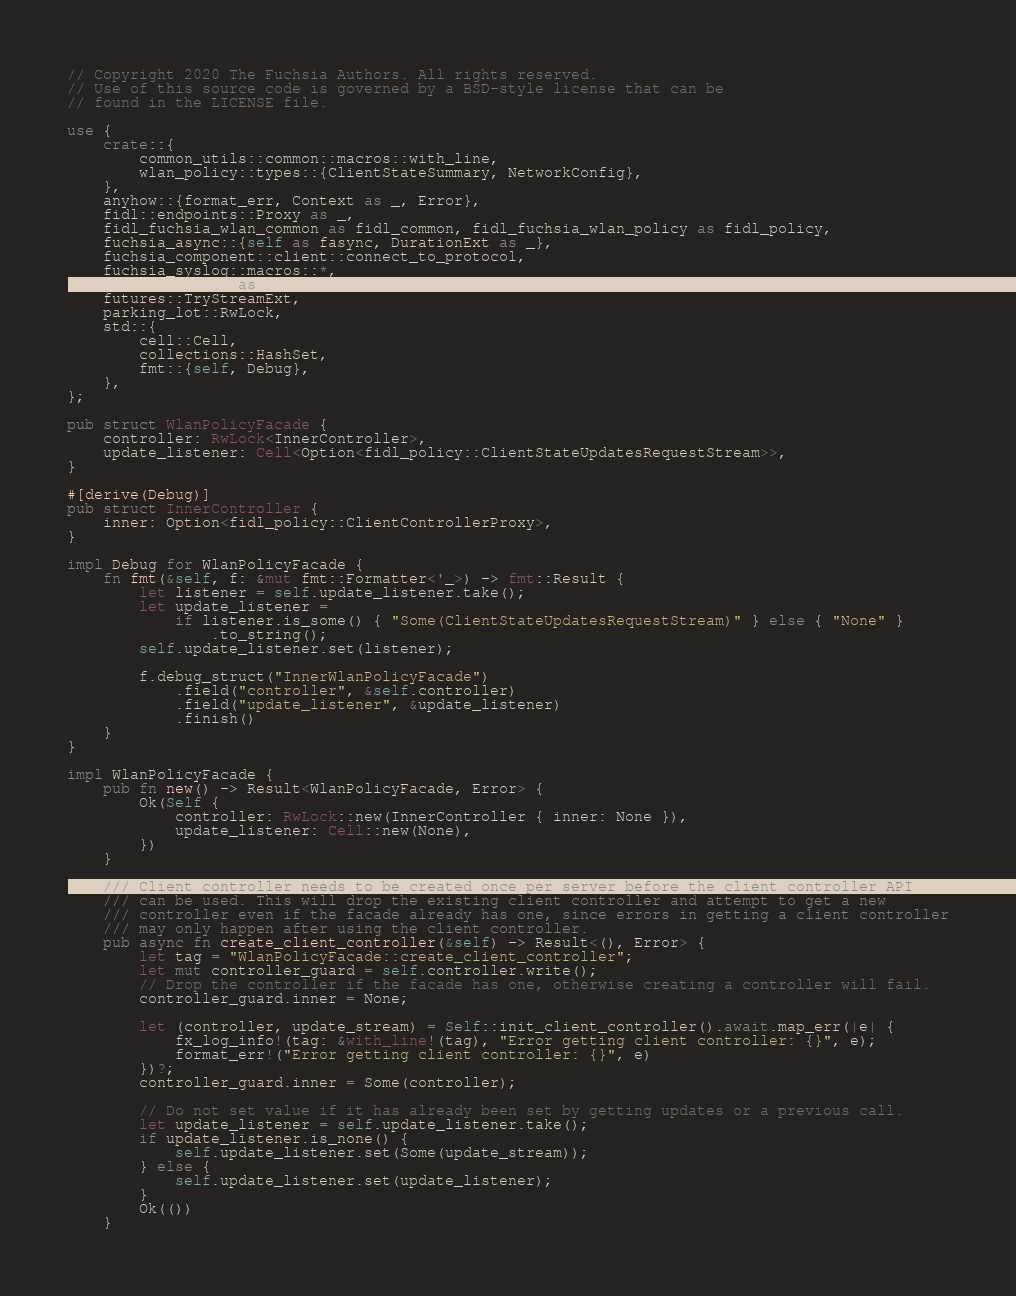<code> <loc_0><loc_0><loc_500><loc_500><_Rust_>// Copyright 2020 The Fuchsia Authors. All rights reserved.
// Use of this source code is governed by a BSD-style license that can be
// found in the LICENSE file.

use {
    crate::{
        common_utils::common::macros::with_line,
        wlan_policy::types::{ClientStateSummary, NetworkConfig},
    },
    anyhow::{format_err, Context as _, Error},
    fidl::endpoints::Proxy as _,
    fidl_fuchsia_wlan_common as fidl_common, fidl_fuchsia_wlan_policy as fidl_policy,
    fuchsia_async::{self as fasync, DurationExt as _},
    fuchsia_component::client::connect_to_protocol,
    fuchsia_syslog::macros::*,
    fuchsia_zircon as zx,
    futures::TryStreamExt,
    parking_lot::RwLock,
    std::{
        cell::Cell,
        collections::HashSet,
        fmt::{self, Debug},
    },
};

pub struct WlanPolicyFacade {
    controller: RwLock<InnerController>,
    update_listener: Cell<Option<fidl_policy::ClientStateUpdatesRequestStream>>,
}

#[derive(Debug)]
pub struct InnerController {
    inner: Option<fidl_policy::ClientControllerProxy>,
}

impl Debug for WlanPolicyFacade {
    fn fmt(&self, f: &mut fmt::Formatter<'_>) -> fmt::Result {
        let listener = self.update_listener.take();
        let update_listener =
            if listener.is_some() { "Some(ClientStateUpdatesRequestStream)" } else { "None" }
                .to_string();
        self.update_listener.set(listener);

        f.debug_struct("InnerWlanPolicyFacade")
            .field("controller", &self.controller)
            .field("update_listener", &update_listener)
            .finish()
    }
}

impl WlanPolicyFacade {
    pub fn new() -> Result<WlanPolicyFacade, Error> {
        Ok(Self {
            controller: RwLock::new(InnerController { inner: None }),
            update_listener: Cell::new(None),
        })
    }

    /// Client controller needs to be created once per server before the client controller API
    /// can be used. This will drop the existing client controller and attempt to get a new
    /// controller even if the facade already has one, since errors in getting a client controller
    /// may only happen after using the client controller.
    pub async fn create_client_controller(&self) -> Result<(), Error> {
        let tag = "WlanPolicyFacade::create_client_controller";
        let mut controller_guard = self.controller.write();
        // Drop the controller if the facade has one, otherwise creating a controller will fail.
        controller_guard.inner = None;

        let (controller, update_stream) = Self::init_client_controller().await.map_err(|e| {
            fx_log_info!(tag: &with_line!(tag), "Error getting client controller: {}", e);
            format_err!("Error getting client controller: {}", e)
        })?;
        controller_guard.inner = Some(controller);

        // Do not set value if it has already been set by getting updates or a previous call.
        let update_listener = self.update_listener.take();
        if update_listener.is_none() {
            self.update_listener.set(Some(update_stream));
        } else {
            self.update_listener.set(update_listener);
        }
        Ok(())
    }
</code> 